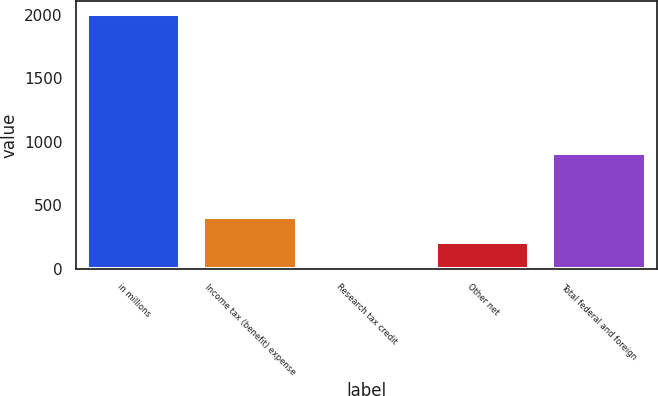Convert chart. <chart><loc_0><loc_0><loc_500><loc_500><bar_chart><fcel>in millions<fcel>Income tax (benefit) expense<fcel>Research tax credit<fcel>Other net<fcel>Total federal and foreign<nl><fcel>2008<fcel>412<fcel>13<fcel>212.5<fcel>913<nl></chart> 